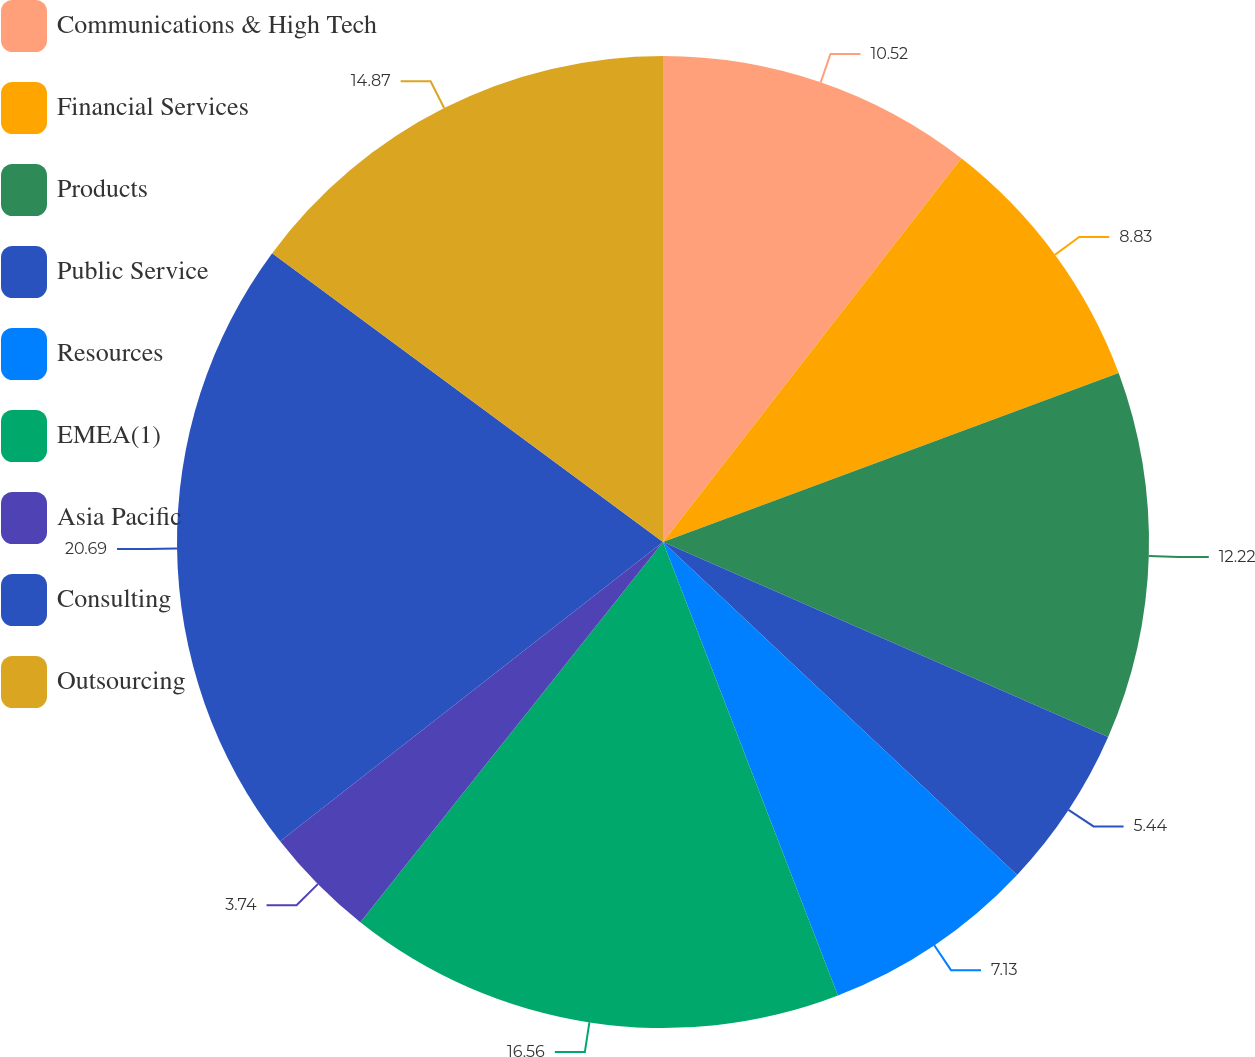Convert chart. <chart><loc_0><loc_0><loc_500><loc_500><pie_chart><fcel>Communications & High Tech<fcel>Financial Services<fcel>Products<fcel>Public Service<fcel>Resources<fcel>EMEA(1)<fcel>Asia Pacific<fcel>Consulting<fcel>Outsourcing<nl><fcel>10.52%<fcel>8.83%<fcel>12.22%<fcel>5.44%<fcel>7.13%<fcel>16.56%<fcel>3.74%<fcel>20.69%<fcel>14.87%<nl></chart> 